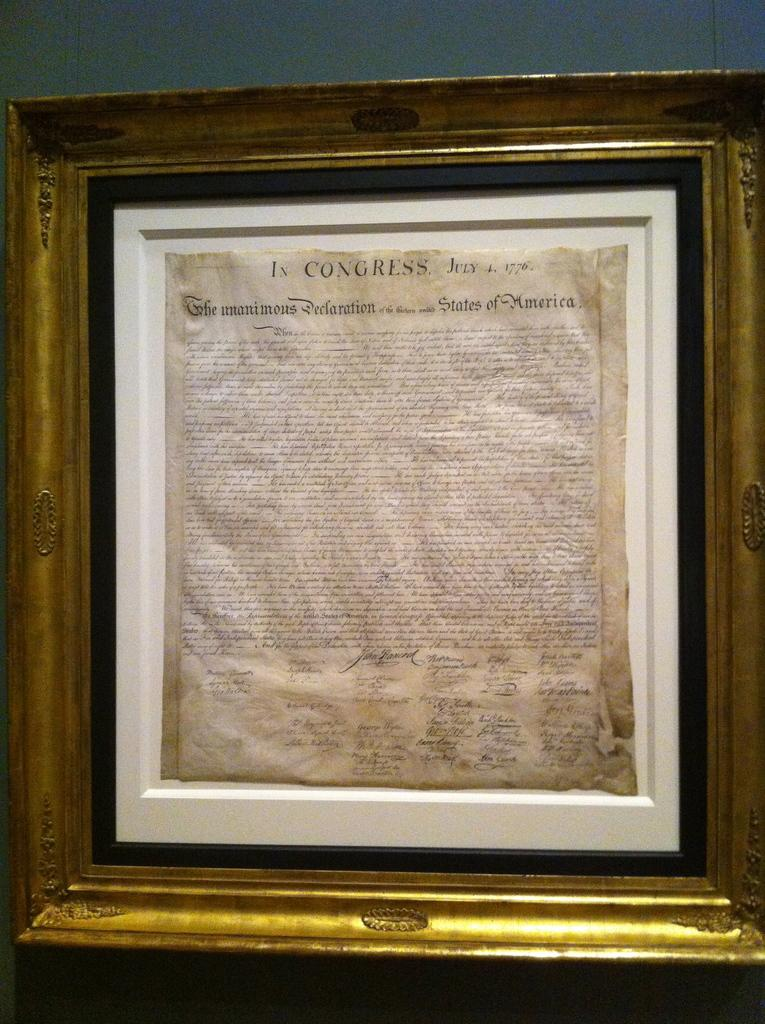<image>
Create a compact narrative representing the image presented. A framed piece of parchment that reads in congress at the top in bold. 